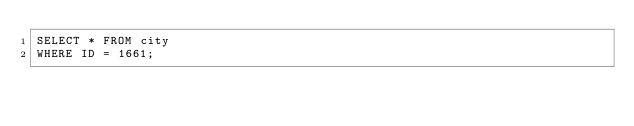Convert code to text. <code><loc_0><loc_0><loc_500><loc_500><_SQL_>SELECT * FROM city
WHERE ID = 1661;</code> 